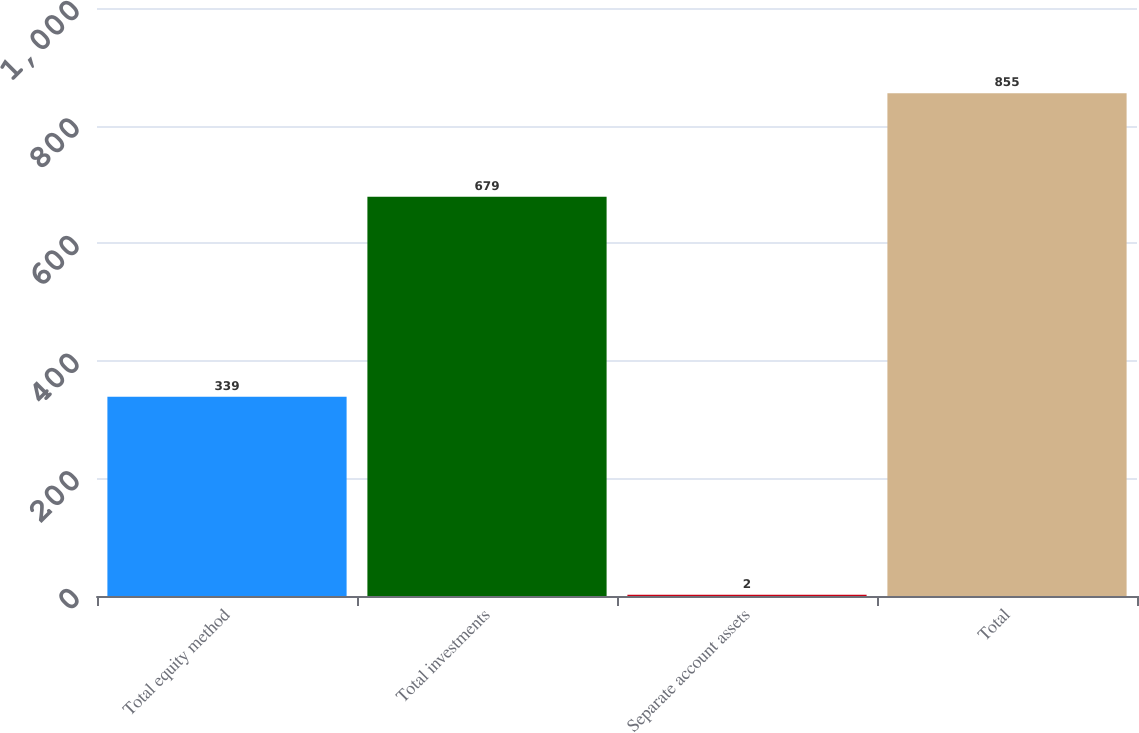Convert chart to OTSL. <chart><loc_0><loc_0><loc_500><loc_500><bar_chart><fcel>Total equity method<fcel>Total investments<fcel>Separate account assets<fcel>Total<nl><fcel>339<fcel>679<fcel>2<fcel>855<nl></chart> 